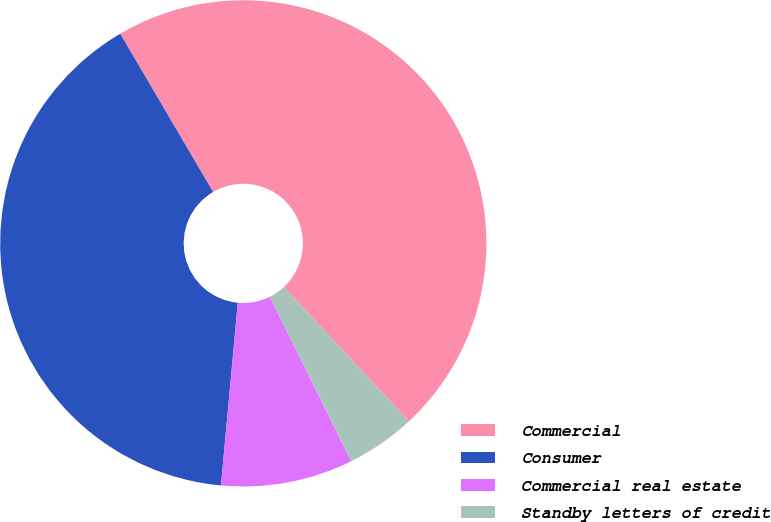Convert chart. <chart><loc_0><loc_0><loc_500><loc_500><pie_chart><fcel>Commercial<fcel>Consumer<fcel>Commercial real estate<fcel>Standby letters of credit<nl><fcel>46.52%<fcel>40.09%<fcel>8.79%<fcel>4.6%<nl></chart> 